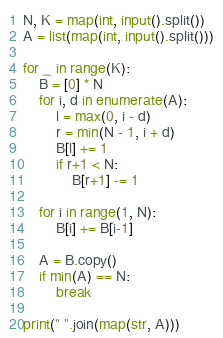<code> <loc_0><loc_0><loc_500><loc_500><_Python_>N, K = map(int, input().split())
A = list(map(int, input().split()))

for _ in range(K):
    B = [0] * N
    for i, d in enumerate(A):
        l = max(0, i - d)
        r = min(N - 1, i + d)
        B[l] += 1
        if r+1 < N:
            B[r+1] -= 1
    
    for i in range(1, N):
        B[i] += B[i-1]
    
    A = B.copy()
    if min(A) == N:
        break

print(" ".join(map(str, A)))</code> 